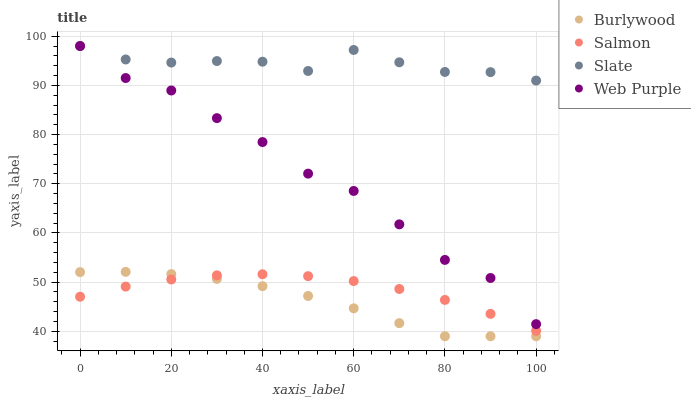Does Burlywood have the minimum area under the curve?
Answer yes or no. Yes. Does Slate have the maximum area under the curve?
Answer yes or no. Yes. Does Salmon have the minimum area under the curve?
Answer yes or no. No. Does Salmon have the maximum area under the curve?
Answer yes or no. No. Is Salmon the smoothest?
Answer yes or no. Yes. Is Web Purple the roughest?
Answer yes or no. Yes. Is Slate the smoothest?
Answer yes or no. No. Is Slate the roughest?
Answer yes or no. No. Does Burlywood have the lowest value?
Answer yes or no. Yes. Does Salmon have the lowest value?
Answer yes or no. No. Does Web Purple have the highest value?
Answer yes or no. Yes. Does Salmon have the highest value?
Answer yes or no. No. Is Burlywood less than Web Purple?
Answer yes or no. Yes. Is Web Purple greater than Burlywood?
Answer yes or no. Yes. Does Web Purple intersect Slate?
Answer yes or no. Yes. Is Web Purple less than Slate?
Answer yes or no. No. Is Web Purple greater than Slate?
Answer yes or no. No. Does Burlywood intersect Web Purple?
Answer yes or no. No. 